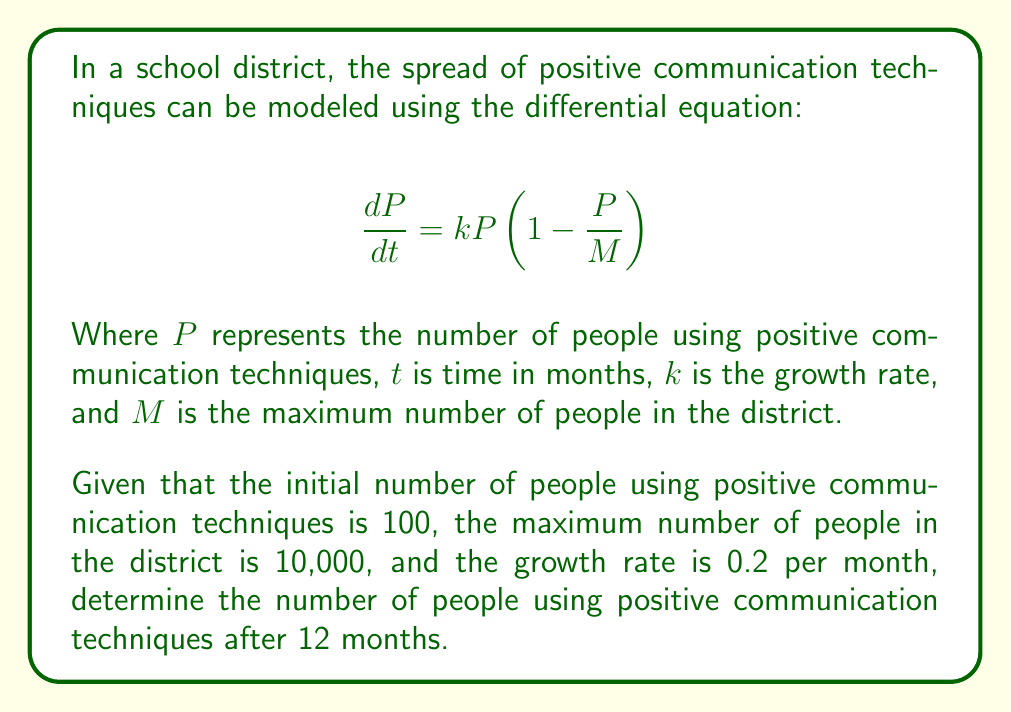Can you solve this math problem? To solve this problem, we need to use the logistic growth model, which is represented by the given differential equation. Let's approach this step-by-step:

1) First, we need to identify the given parameters:
   $P_0 = 100$ (initial population)
   $M = 10,000$ (maximum population)
   $k = 0.2$ (growth rate)
   $t = 12$ (time in months)

2) The solution to the logistic differential equation is:

   $$P(t) = \frac{MP_0}{P_0 + (M-P_0)e^{-kt}}$$

3) Let's substitute our known values into this equation:

   $$P(12) = \frac{10000 \cdot 100}{100 + (10000-100)e^{-0.2 \cdot 12}}$$

4) Simplify:

   $$P(12) = \frac{1000000}{100 + 9900e^{-2.4}}$$

5) Calculate $e^{-2.4}$:

   $$e^{-2.4} \approx 0.0907$$

6) Substitute this value:

   $$P(12) = \frac{1000000}{100 + 9900 \cdot 0.0907} \approx \frac{1000000}{997.93}$$

7) Calculate the final result:

   $$P(12) \approx 1002.07$$

Therefore, after 12 months, approximately 1002 people will be using positive communication techniques.
Answer: Approximately 1002 people 